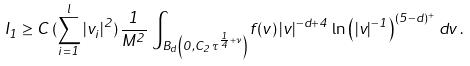<formula> <loc_0><loc_0><loc_500><loc_500>I _ { 1 } \geq C \, ( \sum _ { i = 1 } ^ { l } | v _ { i } | ^ { 2 } ) \, \frac { 1 } { M ^ { 2 } } \, \int _ { B _ { d } \left ( 0 , C _ { 2 } \, \tau ^ { \frac { 1 } { 4 } + \nu } \right ) } f ( v ) \, | v | ^ { - d + 4 } \, \ln \left ( | v | ^ { - 1 } \right ) ^ { ( 5 - d ) ^ { + } } \, d v \, .</formula> 